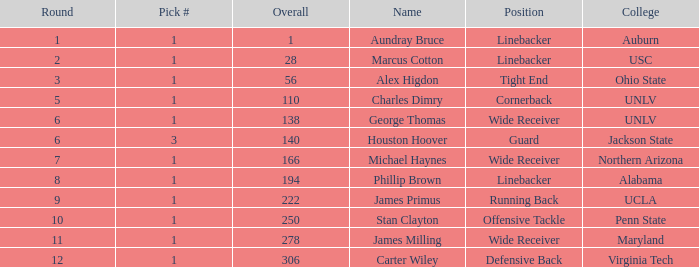What is Aundray Bruce's Pick #? 1.0. 